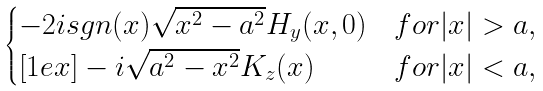<formula> <loc_0><loc_0><loc_500><loc_500>\begin{cases} - 2 i s g n ( x ) \sqrt { x ^ { 2 } - a ^ { 2 } } H _ { y } ( x , 0 ) & f o r | x | > a , \\ [ 1 e x ] - i \sqrt { a ^ { 2 } - x ^ { 2 } } K _ { z } ( x ) & f o r | x | < a , \end{cases}</formula> 